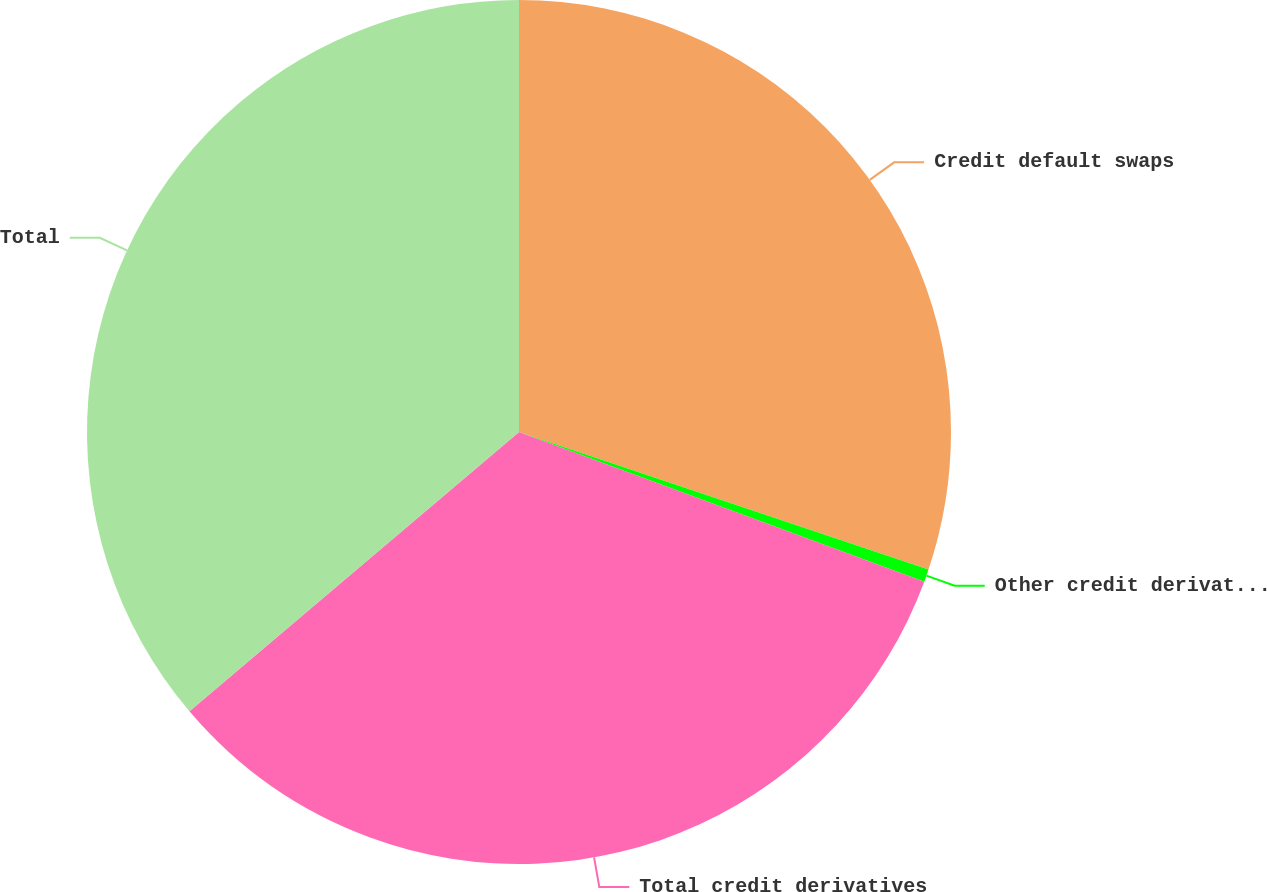Convert chart. <chart><loc_0><loc_0><loc_500><loc_500><pie_chart><fcel>Credit default swaps<fcel>Other credit derivatives (a)<fcel>Total credit derivatives<fcel>Total<nl><fcel>30.16%<fcel>0.47%<fcel>33.18%<fcel>36.19%<nl></chart> 